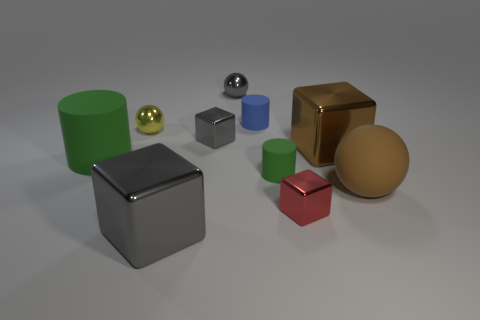What can you infer about the texture of the objects? The objects appear to have a variety of textures. The spheres and the larger cube look glossy and reflective, suggesting a smooth texture, while the other objects have a matte finish, indicating a less reflective, possibly textured surface. 